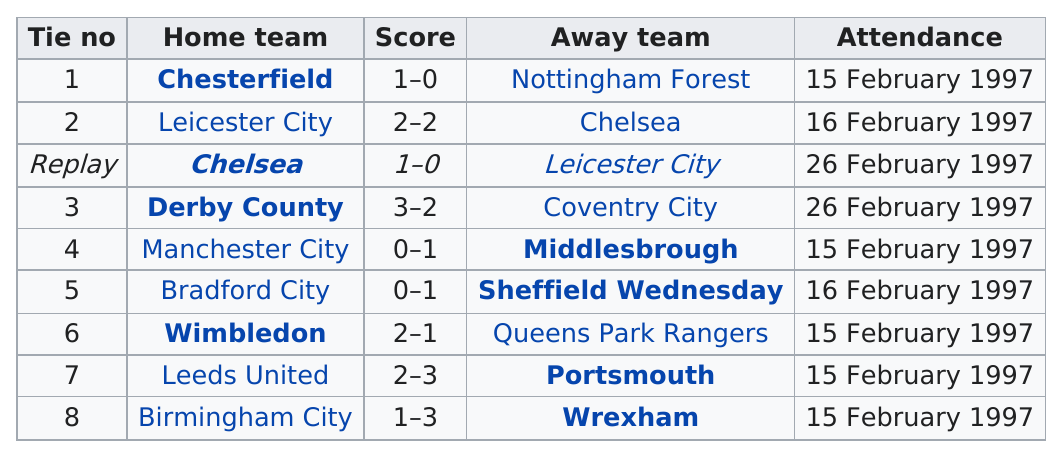Indicate a few pertinent items in this graphic. Chesterfield has a score of 1-0, but the team listed with a score of 2-2 is Leicester City. The away teams have collectively scored a total of 13 points. In the match, Leicester City, Chelsea, Derby County, Coventry City, Wimbledon, Leeds United, Portsmouth, and Wrexham all scored at least two points. Wrexham has won a total of 1 victory in the fifth round proper. Leicester City scored two points in their most recent match. 